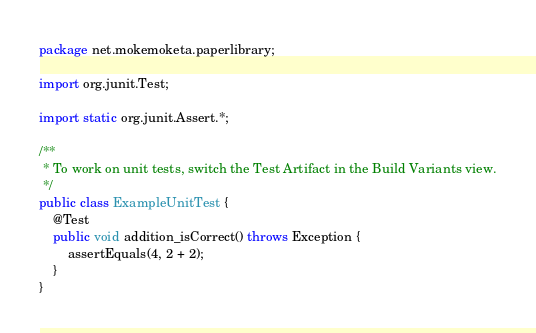Convert code to text. <code><loc_0><loc_0><loc_500><loc_500><_Java_>package net.mokemoketa.paperlibrary;

import org.junit.Test;

import static org.junit.Assert.*;

/**
 * To work on unit tests, switch the Test Artifact in the Build Variants view.
 */
public class ExampleUnitTest {
    @Test
    public void addition_isCorrect() throws Exception {
        assertEquals(4, 2 + 2);
    }
}</code> 